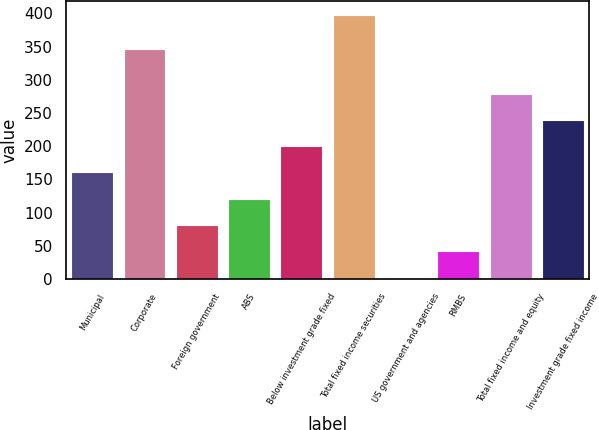<chart> <loc_0><loc_0><loc_500><loc_500><bar_chart><fcel>Municipal<fcel>Corporate<fcel>Foreign government<fcel>ABS<fcel>Below investment grade fixed<fcel>Total fixed income securities<fcel>US government and agencies<fcel>RMBS<fcel>Total fixed income and equity<fcel>Investment grade fixed income<nl><fcel>160.4<fcel>347<fcel>81.2<fcel>120.8<fcel>200<fcel>398<fcel>2<fcel>41.6<fcel>279.2<fcel>239.6<nl></chart> 